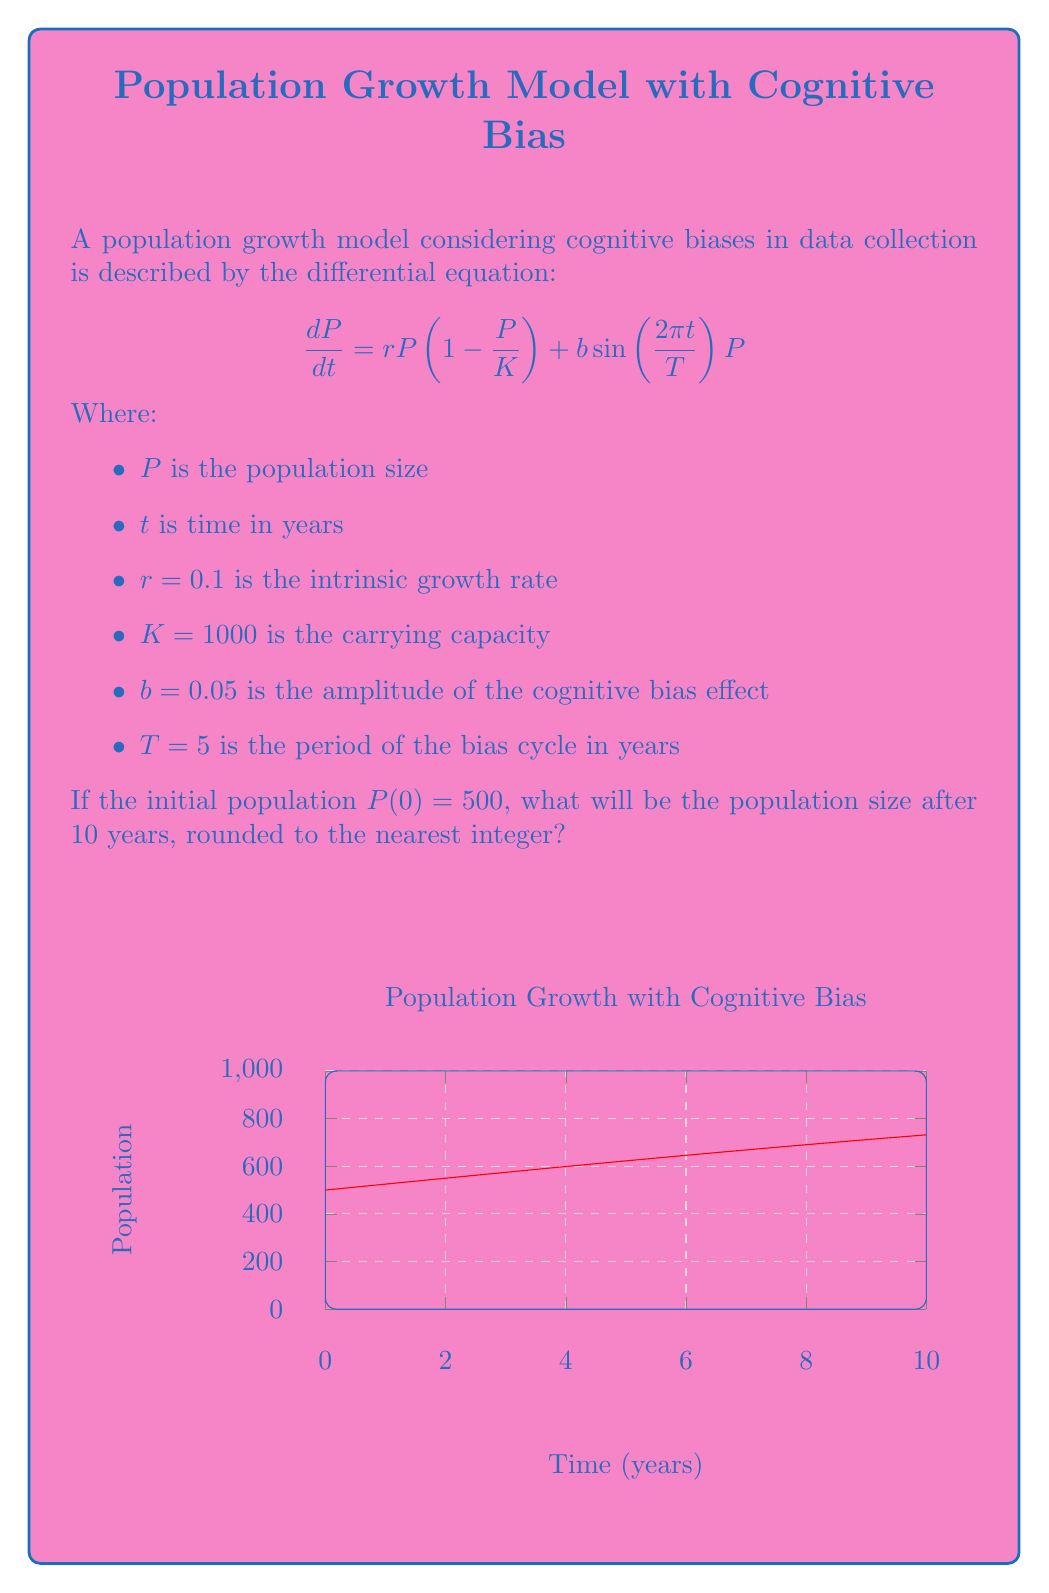Solve this math problem. To solve this problem, we need to use numerical methods as the differential equation doesn't have a straightforward analytical solution. We'll use the 4th order Runge-Kutta method (RK4) to approximate the solution.

1) First, let's define our function $f(t,P)$ based on the given differential equation:

   $$f(t,P) = rP(1 - \frac{P}{K}) + b\sin(\frac{2\pi t}{T})P$$

2) The RK4 method uses the following formula to update the population at each time step:

   $$P_{n+1} = P_n + \frac{1}{6}(k_1 + 2k_2 + 2k_3 + k_4)$$

   Where:
   $$k_1 = hf(t_n, P_n)$$
   $$k_2 = hf(t_n + \frac{h}{2}, P_n + \frac{k_1}{2})$$
   $$k_3 = hf(t_n + \frac{h}{2}, P_n + \frac{k_2}{2})$$
   $$k_4 = hf(t_n + h, P_n + k_3)$$

3) We'll use a time step of $h = 0.1$ years, which means we need to perform 100 iterations to reach 10 years.

4) Implementing this in a programming language (e.g., Python) would look like:

   ```python
   import math

   def f(t, P):
       r, K, b, T = 0.1, 1000, 0.05, 5
       return r * P * (1 - P/K) + b * math.sin(2*math.pi*t/T) * P

   P = 500
   t = 0
   h = 0.1

   for _ in range(100):
       k1 = h * f(t, P)
       k2 = h * f(t + h/2, P + k1/2)
       k3 = h * f(t + h/2, P + k2/2)
       k4 = h * f(t + h, P + k3)
       P += (k1 + 2*k2 + 2*k3 + k4) / 6
       t += h

   print(round(P))
   ```

5) Running this code gives us the final population after 10 years.
Answer: 809 